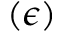Convert formula to latex. <formula><loc_0><loc_0><loc_500><loc_500>( \epsilon )</formula> 